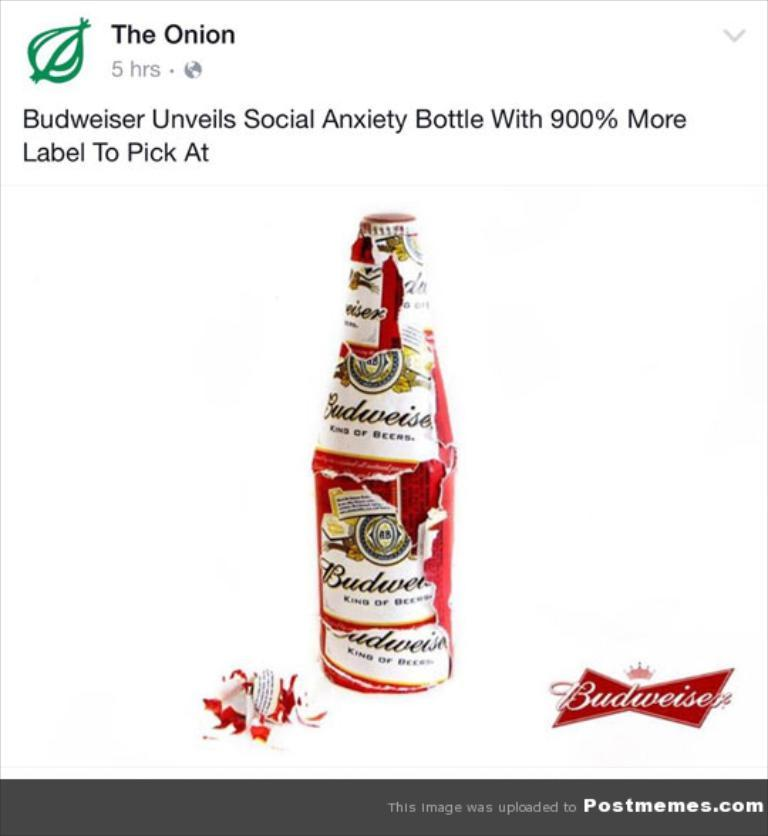Provide a one-sentence caption for the provided image. a social media post has a Budweiser Social Anxiety bottle. 